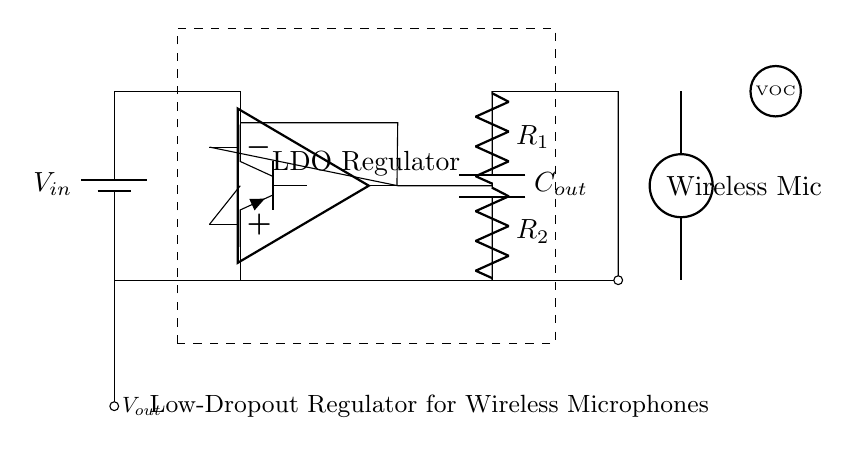What is the input voltage of the circuit? The input voltage is represented as V_in, which is the voltage supplied to the regulator.
Answer: V_in What type of transistor is used in the regulator? The circuit diagram shows a PNP transistor, indicated by the symbol and the label Q1.
Answer: PNP What is the purpose of the error amplifier? The error amplifier in the circuit compares the output voltage to a reference voltage and adjusts the pass transistor to maintain the desired output voltage.
Answer: Maintain output voltage What do R1 and R2 represent in this circuit? R1 and R2 are resistors that form a feedback network, which is used by the error amplifier to set the output voltage.
Answer: Resistors for feedback Why is it important for the regulator to be a low-dropout type? A low-dropout regulator is crucial for providing a stable output voltage with a small difference between input and output voltages, which is important for battery-powered applications like wireless microphones.
Answer: Stability in low input-output voltage difference What is the function of the output capacitor C_out? C_out smooths the output voltage and helps reduce voltage ripple, ensuring a clean power supply for the wireless microphone.
Answer: Smooths output voltage 